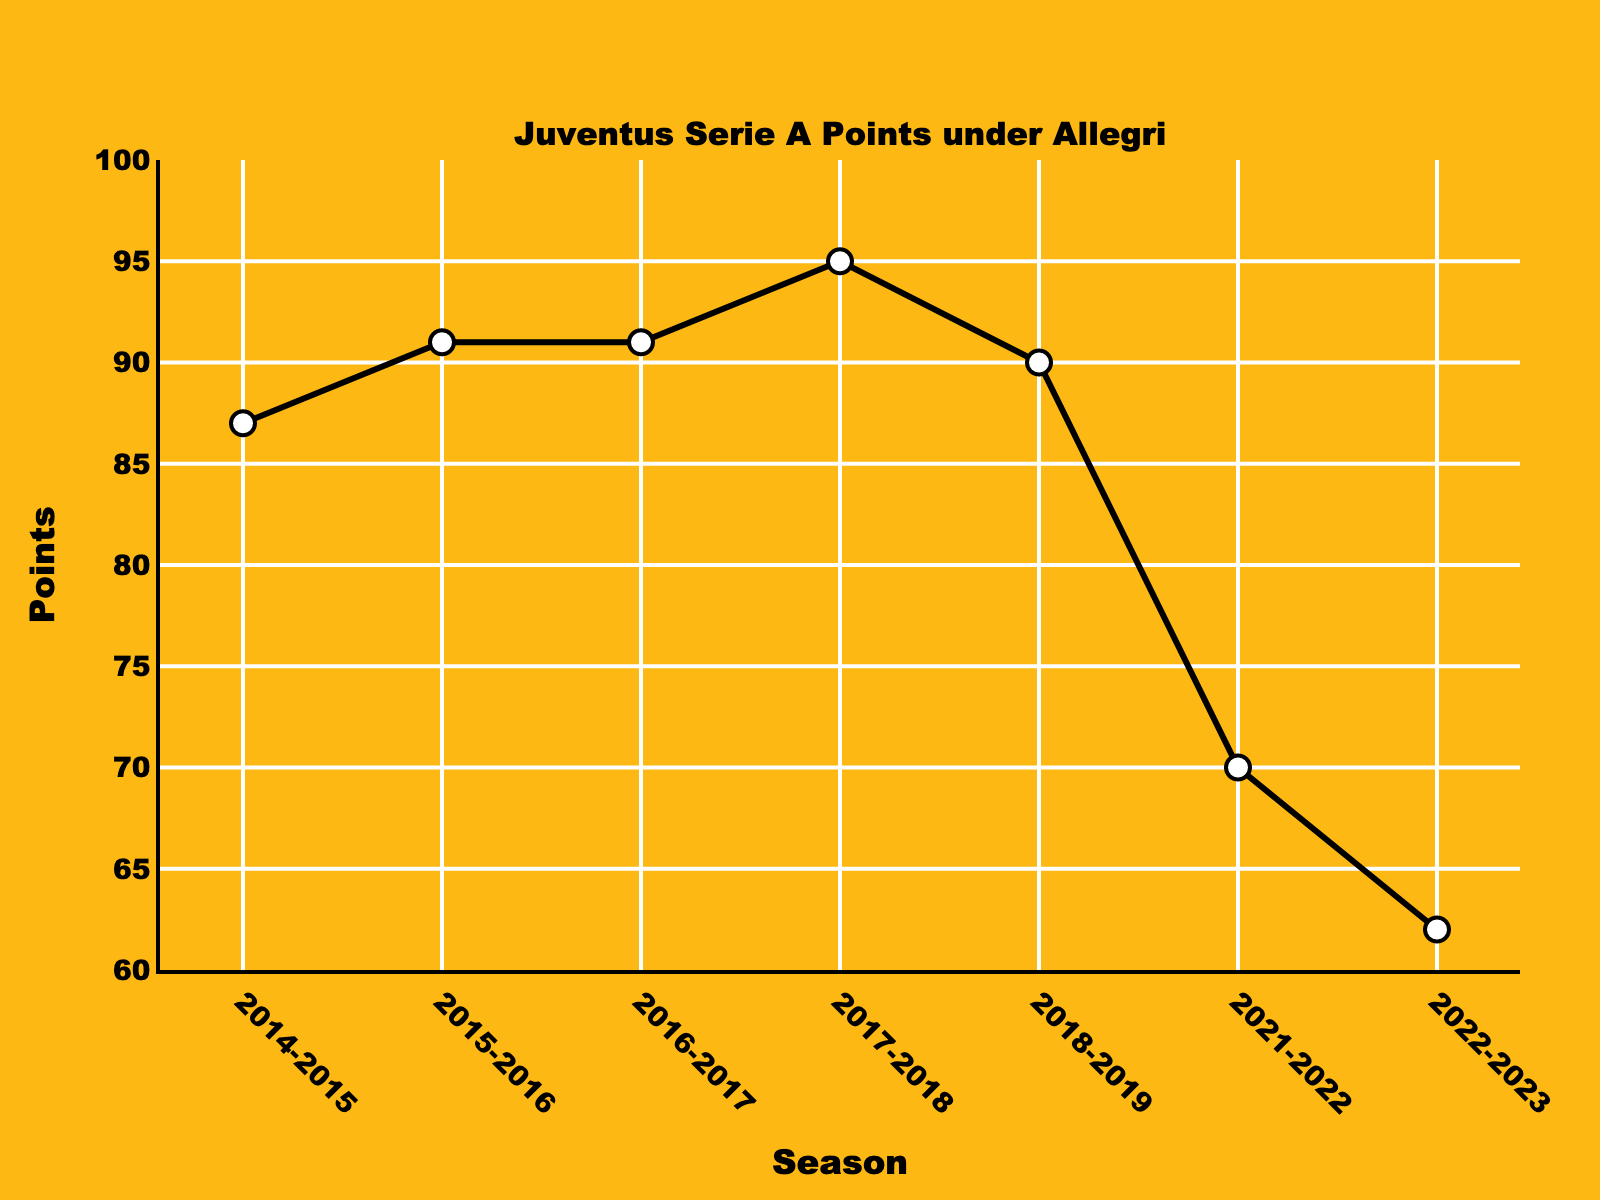Which season did Juventus achieve the highest points under Allegri? Look at the highest point on the y-axis. It corresponds to the 2017-2018 season, where Juventus achieved 95 points.
Answer: 2017-2018 How many seasons did Juventus have more than 90 points? Identify the seasons with points greater than 90. The seasons 2015-2016, 2016-2017, and 2017-2018 meet this criterion.
Answer: 3 What is the average number of points from 2014-2019 compared to 2021-2023? Calculate the average points for 2014-2019 (87+91+91+95+90) / 5 = 90.8, and for 2021-2023 (70+62) / 2 = 66. Compare the two averages, 90.8 > 66.
Answer: 90.8 > 66 In which season did Juventus experience the largest drop in points from the previous season? Calculate the yearly point differences. The largest drop is from the 2018-2019 season (90 points) to the 2021-2022 season (70 points), a difference of 20 points.
Answer: 2018-2019 to 2021-2022 How many seasons did Juventus have fewer than 70 points under Allegri? Identify seasons with points fewer than 70. Only the 2022-2023 season had 62 points.
Answer: 1 What is the median number of points achieved in the listed seasons? Sort the points: 62, 70, 87, 90, 91, 91, 95. The median is the fourth value, which is 90.
Answer: 90 Which two consecutive seasons show the same number of points? Look for identical points in consecutive seasons. The seasons 2015-2016 and 2016-2017 both have 91 points.
Answer: 2015-2016 and 2016-2017 By how many points did Juventus's performance improve from 2014-2015 to 2015-2016? Subtract the points in 2014-2015 (87) from the points in 2015-2016 (91), which is 91 - 87 = 4.
Answer: 4 Which season saw the lowest number of points for Juventus under Allegri? Identify the lowest point on the y-axis, which corresponds to the 2022-2023 season with 62 points.
Answer: 2022-2023 What is the sum of Juventus's points in the seasons where they achieved over 90 points? Sum the points of the seasons with over 90 points: 91 + 91 + 95 = 277.
Answer: 277 